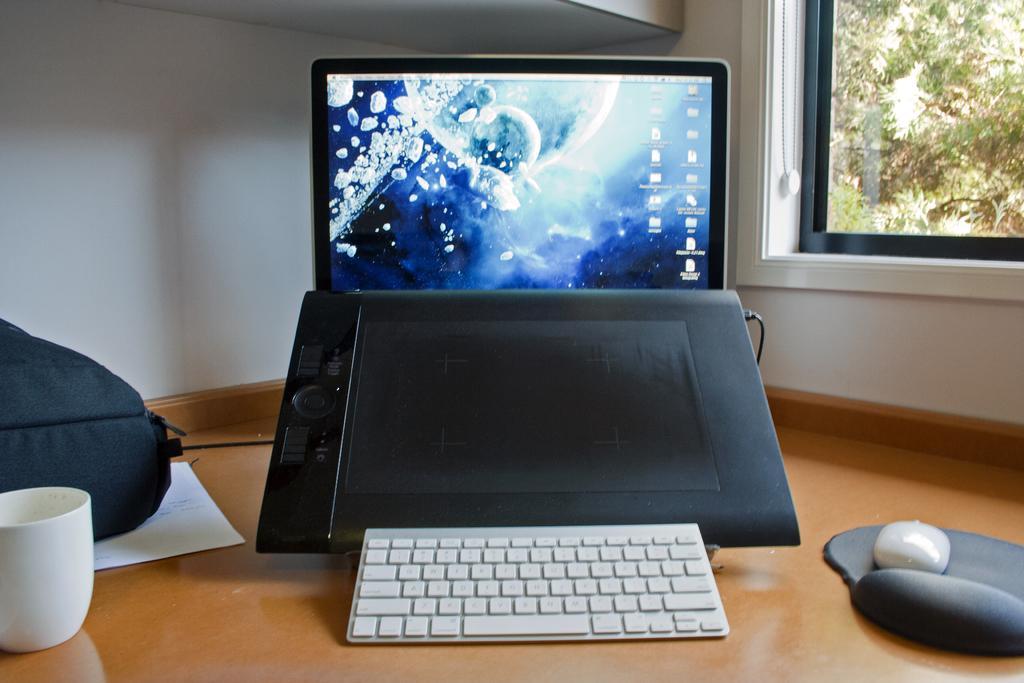Describe this image in one or two sentences. In the middle there is a laptop, on the left side there is a cup. On the right side there is a glass window. 